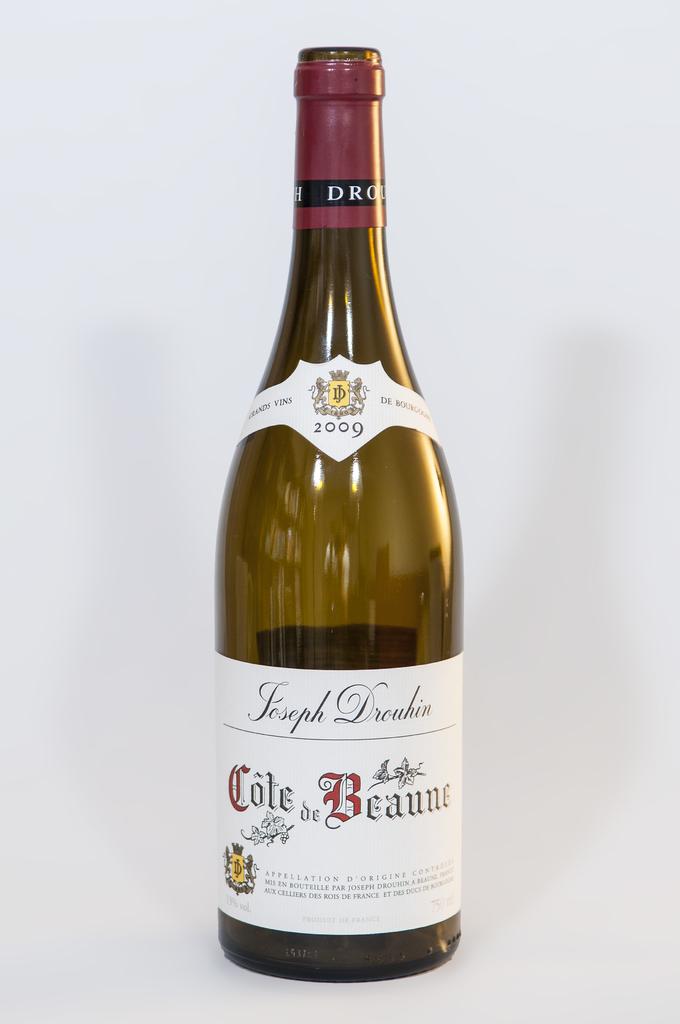What brand name is the bottle?
Ensure brevity in your answer.  Cole de beaune. 